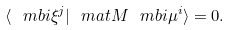<formula> <loc_0><loc_0><loc_500><loc_500>\langle \ m b i \xi ^ { j } | \ m a t M \ m b i \mu ^ { i } \rangle = 0 { . }</formula> 